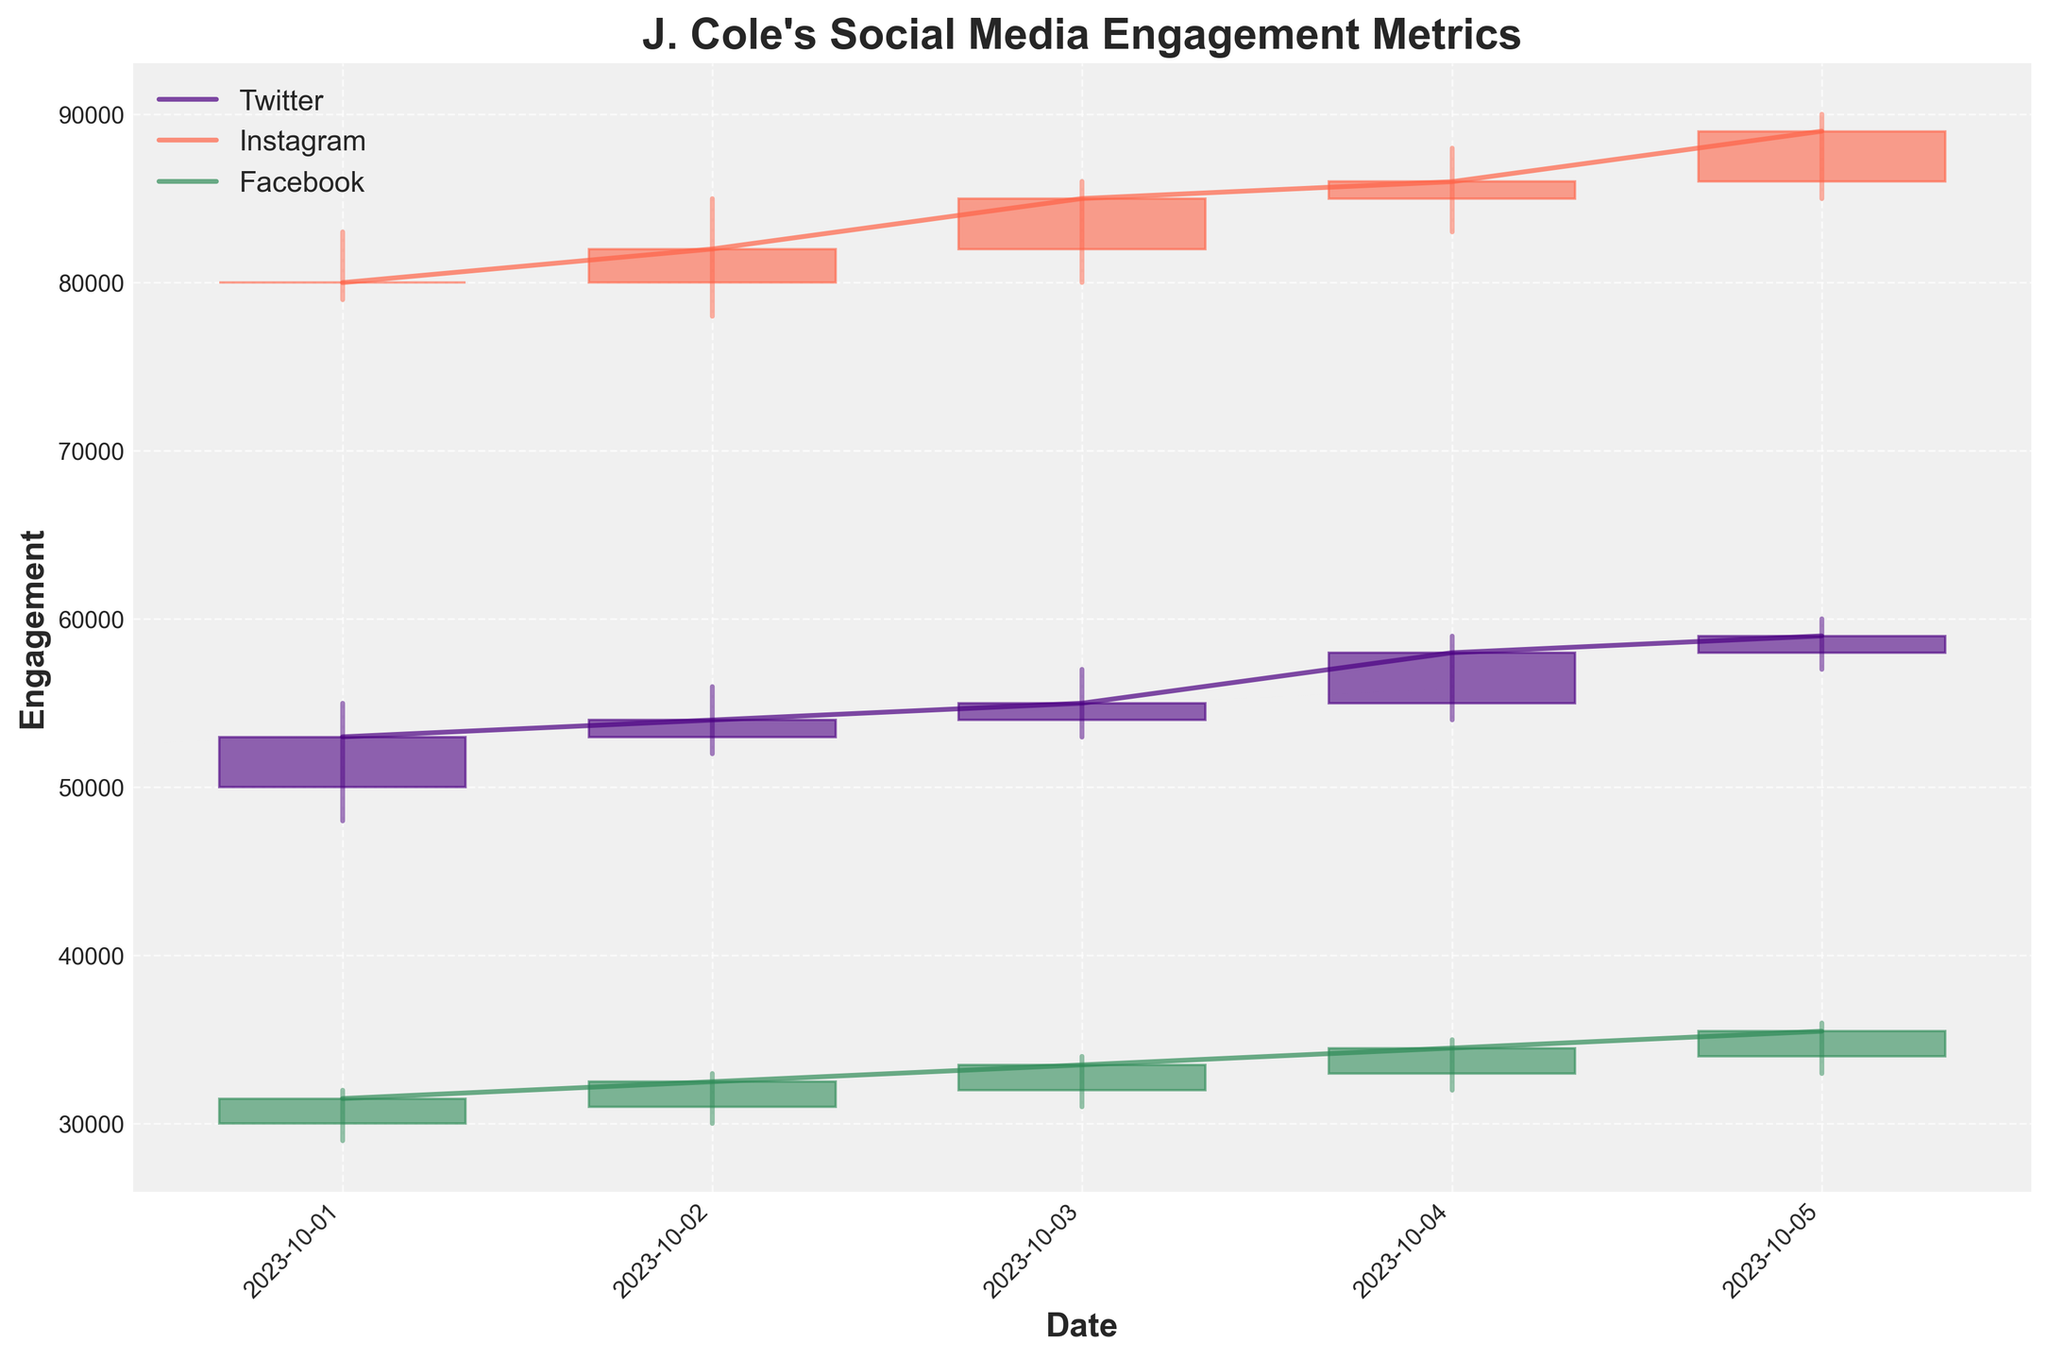What is the highest engagement for Twitter on October 3, 2023? To find the highest engagement for Twitter on October 3, 2023, look at the 'High' value for Twitter on that date.
Answer: 57000 Which platform had the highest engagement on October 5, 2023? Compare the 'High' values across all platforms on October 5, 2023. Instagram has the highest 'High' value of 90000.
Answer: Instagram What is the difference between the closing engagement values of Twitter and Facebook on October 2, 2023? Subtract the 'Close' value of Facebook from the 'Close' value of Twitter on October 2, 2023: 54000 (Twitter) - 32500 (Facebook) = 21500.
Answer: 21500 How does the closing engagement trend for Instagram from October 1 to October 5, 2023? Check the 'Close' values for Instagram from October 1 to October 5. The values are 80000, 82000, 85000, 86000, and 89000, indicating a consistent upward trend.
Answer: Upward trend Which day had the lowest engagement on Facebook, and what was that value? Look at the 'Low' values for Facebook across all dates: the lowest 'Low' value for Facebook is 29000 on October 1, 2023.
Answer: October 1, 2023, with 29000 What is the average closing engagement for Facebook over the provided dates? Sum the 'Close' values of Facebook for all dates and divide by the number of dates: (31500 + 32500 + 33500 + 34500 + 35500) / 5 = 33400.
Answer: 33400 Which platform had more consistent (less fluctuating) engagement values from October 1 to October 5, Twitter or Instagram? Compare the range (High - Low) of engagement values for Twitter and Instagram over the given dates. Twitter values range from 60000 to 52000, and Instagram values range from 90000 to 78000. Twitter has a narrower range.
Answer: Twitter On which day did Instagram see its highest single day's engagement increase from the opening to the closing value? To find the highest single day's engagement increase on Instagram, subtract the 'Open' value from the 'Close' value for each date and find the maximum difference: October 5, with an increase of 3000 (89000 - 86000).
Answer: October 5 What are the colors used for representing each platform in the plot? Identify the colors used in the plot for each platform. (Twitter: purple, Instagram: tomato, Facebook: green).
Answer: Twitter: purple, Instagram: tomato, Facebook: green On which date did all three platforms have their closing values higher than their opening values? Review the 'Close' and 'Open' values for all three platforms on each date to see when all 'Close' values are greater than 'Open' values. This occurs on October 3, 2023.
Answer: October 3, 2023 